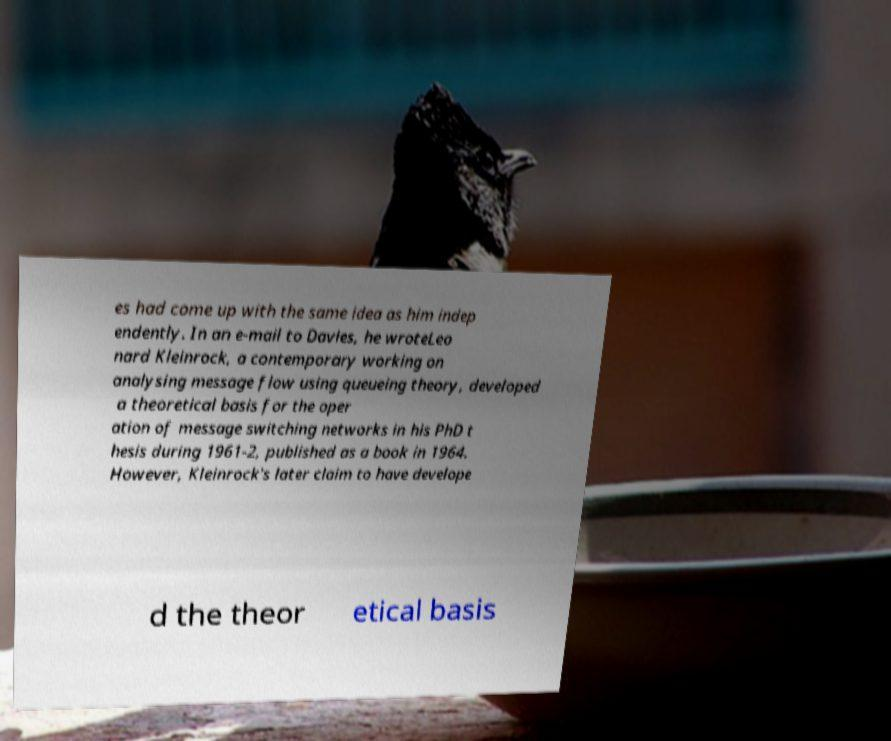I need the written content from this picture converted into text. Can you do that? es had come up with the same idea as him indep endently. In an e-mail to Davies, he wroteLeo nard Kleinrock, a contemporary working on analysing message flow using queueing theory, developed a theoretical basis for the oper ation of message switching networks in his PhD t hesis during 1961-2, published as a book in 1964. However, Kleinrock's later claim to have develope d the theor etical basis 